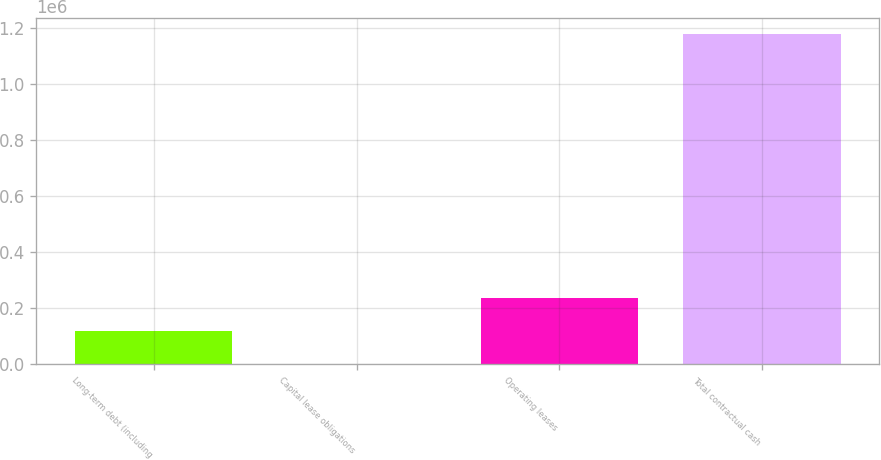Convert chart. <chart><loc_0><loc_0><loc_500><loc_500><bar_chart><fcel>Long-term debt (including<fcel>Capital lease obligations<fcel>Operating leases<fcel>Total contractual cash<nl><fcel>118359<fcel>722<fcel>235996<fcel>1.17709e+06<nl></chart> 